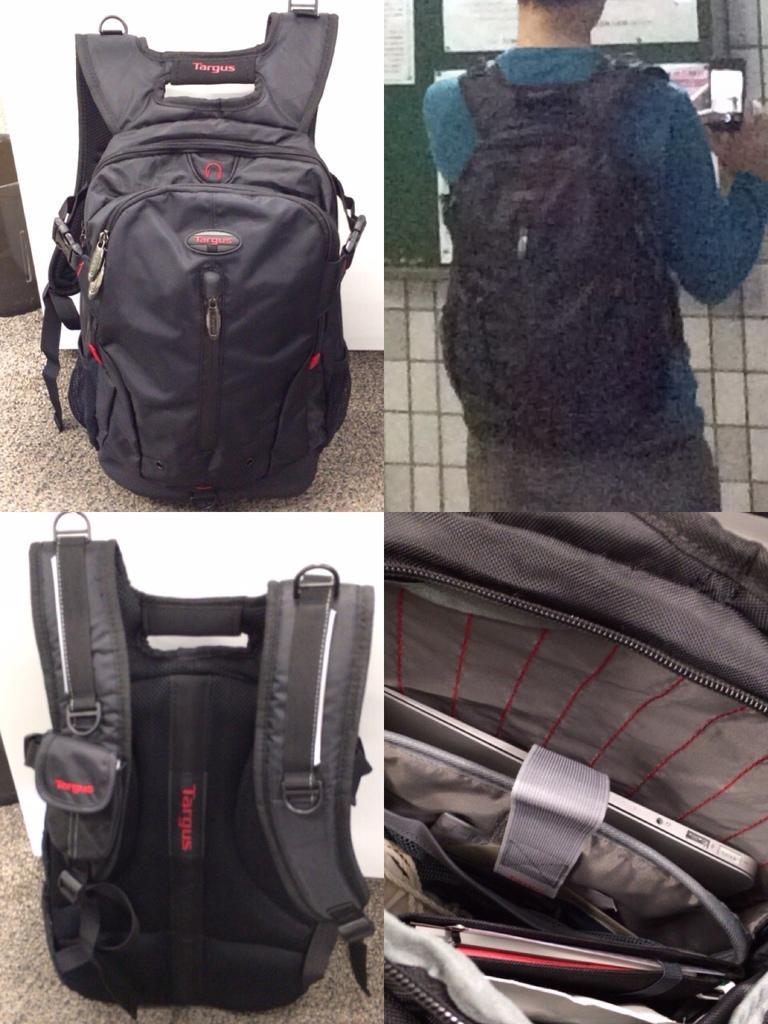Could you give a brief overview of what you see in this image? This is an edited image. This picture is the collage of four images. In the left top, we see a black bag is placed on the carpet. Behind that, we see a white wall. In the left bottom, we see a black bag. Behind that, we see a wall. In the right top, we see a man is wearing the bag and he is holding a mobile phone. In front of him, we see a wall on which notice board is placed. We see some posts are posted on the board. In the right bottom, we see a bag in which laptop and a book are placed. 